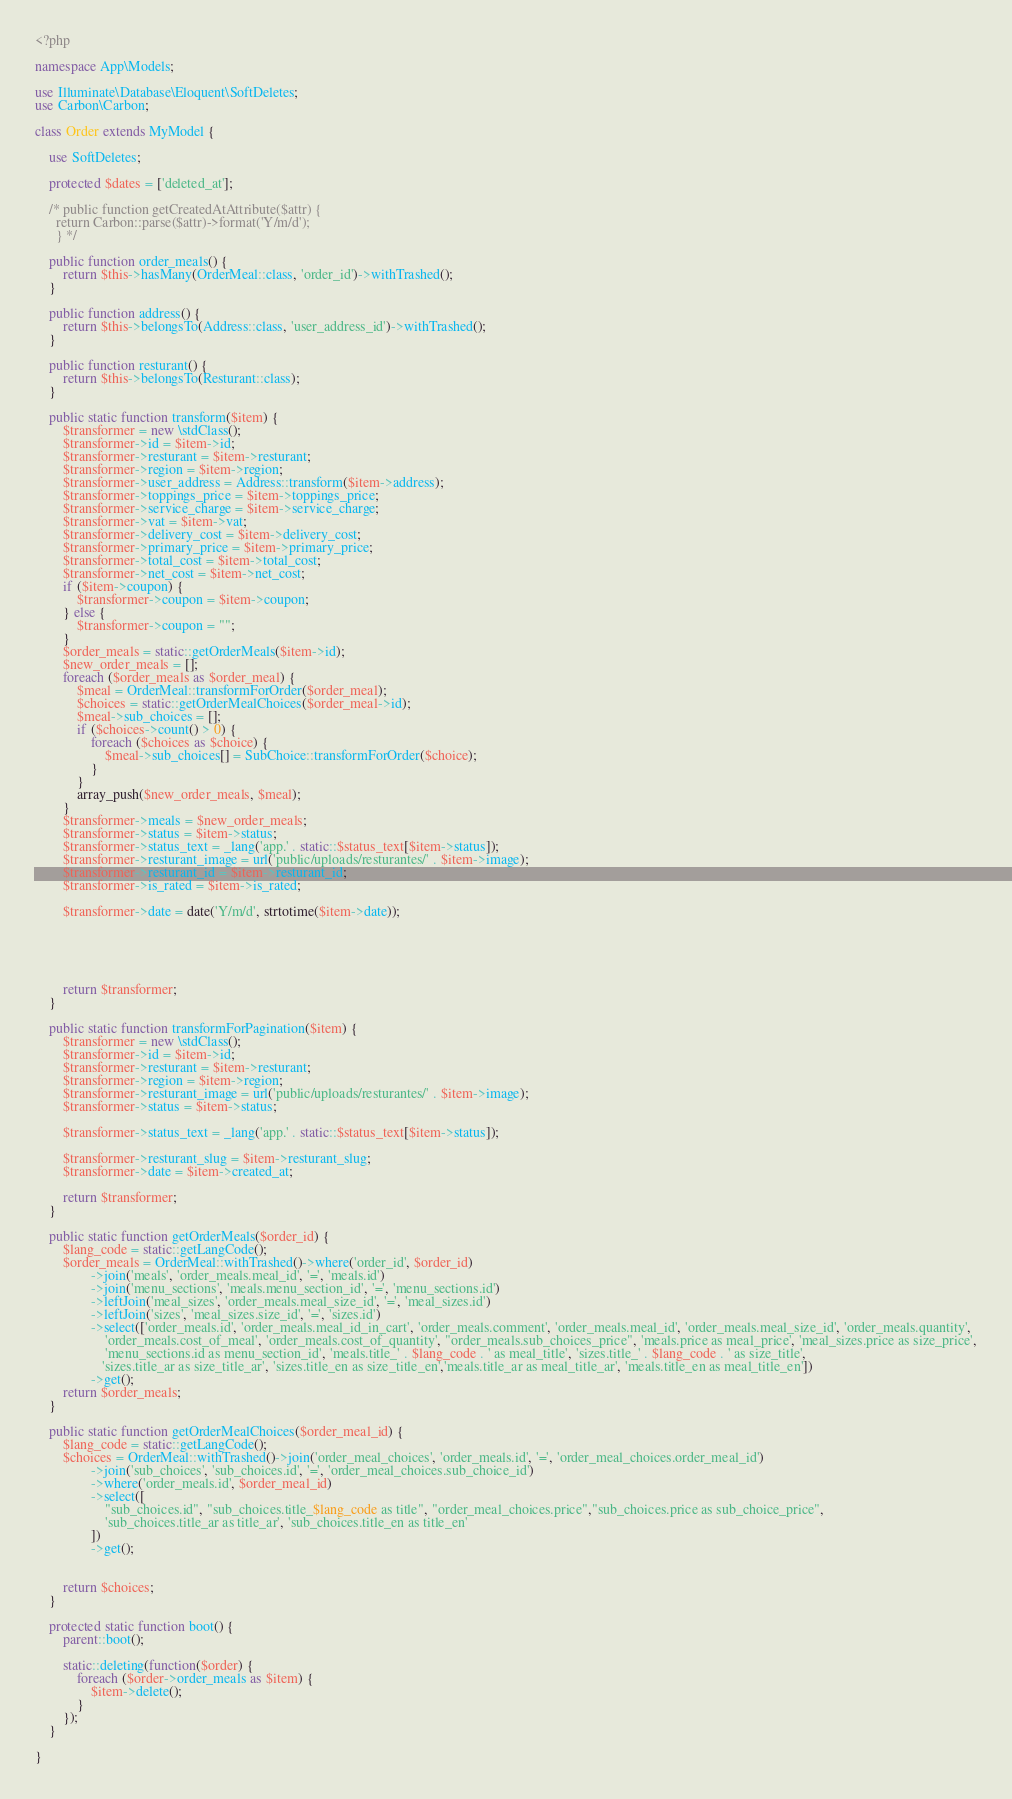Convert code to text. <code><loc_0><loc_0><loc_500><loc_500><_PHP_><?php

namespace App\Models;

use Illuminate\Database\Eloquent\SoftDeletes;
use Carbon\Carbon;

class Order extends MyModel {

    use SoftDeletes;

    protected $dates = ['deleted_at'];

    /* public function getCreatedAtAttribute($attr) {
      return Carbon::parse($attr)->format('Y/m/d');
      } */

    public function order_meals() {
        return $this->hasMany(OrderMeal::class, 'order_id')->withTrashed();
    }

    public function address() {
        return $this->belongsTo(Address::class, 'user_address_id')->withTrashed();
    }

    public function resturant() {
        return $this->belongsTo(Resturant::class);
    }

    public static function transform($item) {
        $transformer = new \stdClass();
        $transformer->id = $item->id;
        $transformer->resturant = $item->resturant;
        $transformer->region = $item->region;
        $transformer->user_address = Address::transform($item->address);
        $transformer->toppings_price = $item->toppings_price;
        $transformer->service_charge = $item->service_charge;
        $transformer->vat = $item->vat;
        $transformer->delivery_cost = $item->delivery_cost;
        $transformer->primary_price = $item->primary_price;
        $transformer->total_cost = $item->total_cost;
        $transformer->net_cost = $item->net_cost;
        if ($item->coupon) {
            $transformer->coupon = $item->coupon;
        } else {
            $transformer->coupon = "";
        }
        $order_meals = static::getOrderMeals($item->id);
        $new_order_meals = [];
        foreach ($order_meals as $order_meal) {
            $meal = OrderMeal::transformForOrder($order_meal);
            $choices = static::getOrderMealChoices($order_meal->id);
            $meal->sub_choices = [];
            if ($choices->count() > 0) {
                foreach ($choices as $choice) {
                    $meal->sub_choices[] = SubChoice::transformForOrder($choice);
                }
            }
            array_push($new_order_meals, $meal);
        }
        $transformer->meals = $new_order_meals;
        $transformer->status = $item->status;
        $transformer->status_text = _lang('app.' . static::$status_text[$item->status]);
        $transformer->resturant_image = url('public/uploads/resturantes/' . $item->image);
        $transformer->resturant_id = $item->resturant_id;
        $transformer->is_rated = $item->is_rated;

        $transformer->date = date('Y/m/d', strtotime($item->date));





        return $transformer;
    }

    public static function transformForPagination($item) {
        $transformer = new \stdClass();
        $transformer->id = $item->id;
        $transformer->resturant = $item->resturant;
        $transformer->region = $item->region;
        $transformer->resturant_image = url('public/uploads/resturantes/' . $item->image);
        $transformer->status = $item->status;

        $transformer->status_text = _lang('app.' . static::$status_text[$item->status]);

        $transformer->resturant_slug = $item->resturant_slug;
        $transformer->date = $item->created_at;

        return $transformer;
    }

    public static function getOrderMeals($order_id) {
        $lang_code = static::getLangCode();
        $order_meals = OrderMeal::withTrashed()->where('order_id', $order_id)
                ->join('meals', 'order_meals.meal_id', '=', 'meals.id')
                ->join('menu_sections', 'meals.menu_section_id', '=', 'menu_sections.id')
                ->leftJoin('meal_sizes', 'order_meals.meal_size_id', '=', 'meal_sizes.id')
                ->leftJoin('sizes', 'meal_sizes.size_id', '=', 'sizes.id')
                ->select(['order_meals.id', 'order_meals.meal_id_in_cart', 'order_meals.comment', 'order_meals.meal_id', 'order_meals.meal_size_id', 'order_meals.quantity',
                    'order_meals.cost_of_meal', 'order_meals.cost_of_quantity', "order_meals.sub_choices_price", 'meals.price as meal_price', 'meal_sizes.price as size_price',
                    'menu_sections.id as menu_section_id', 'meals.title_' . $lang_code . ' as meal_title', 'sizes.title_' . $lang_code . ' as size_title',
                   'sizes.title_ar as size_title_ar', 'sizes.title_en as size_title_en','meals.title_ar as meal_title_ar', 'meals.title_en as meal_title_en'])
                ->get();
        return $order_meals;
    }

    public static function getOrderMealChoices($order_meal_id) {
        $lang_code = static::getLangCode();
        $choices = OrderMeal::withTrashed()->join('order_meal_choices', 'order_meals.id', '=', 'order_meal_choices.order_meal_id')
                ->join('sub_choices', 'sub_choices.id', '=', 'order_meal_choices.sub_choice_id')
                ->where('order_meals.id', $order_meal_id)
                ->select([
                    "sub_choices.id", "sub_choices.title_$lang_code as title", "order_meal_choices.price","sub_choices.price as sub_choice_price",
                    'sub_choices.title_ar as title_ar', 'sub_choices.title_en as title_en'
                ])
                ->get();


        return $choices;
    }

    protected static function boot() {
        parent::boot();

        static::deleting(function($order) {
            foreach ($order->order_meals as $item) {
                $item->delete();
            }
        });
    }

}
</code> 